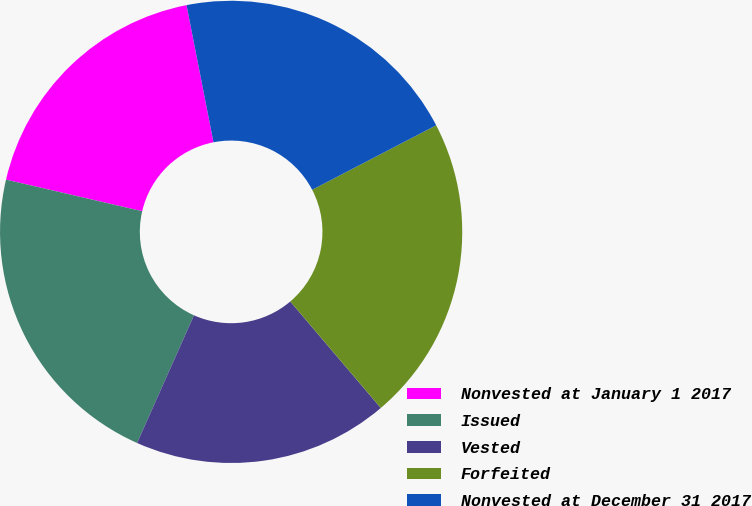Convert chart. <chart><loc_0><loc_0><loc_500><loc_500><pie_chart><fcel>Nonvested at January 1 2017<fcel>Issued<fcel>Vested<fcel>Forfeited<fcel>Nonvested at December 31 2017<nl><fcel>18.28%<fcel>21.96%<fcel>17.88%<fcel>21.42%<fcel>20.46%<nl></chart> 